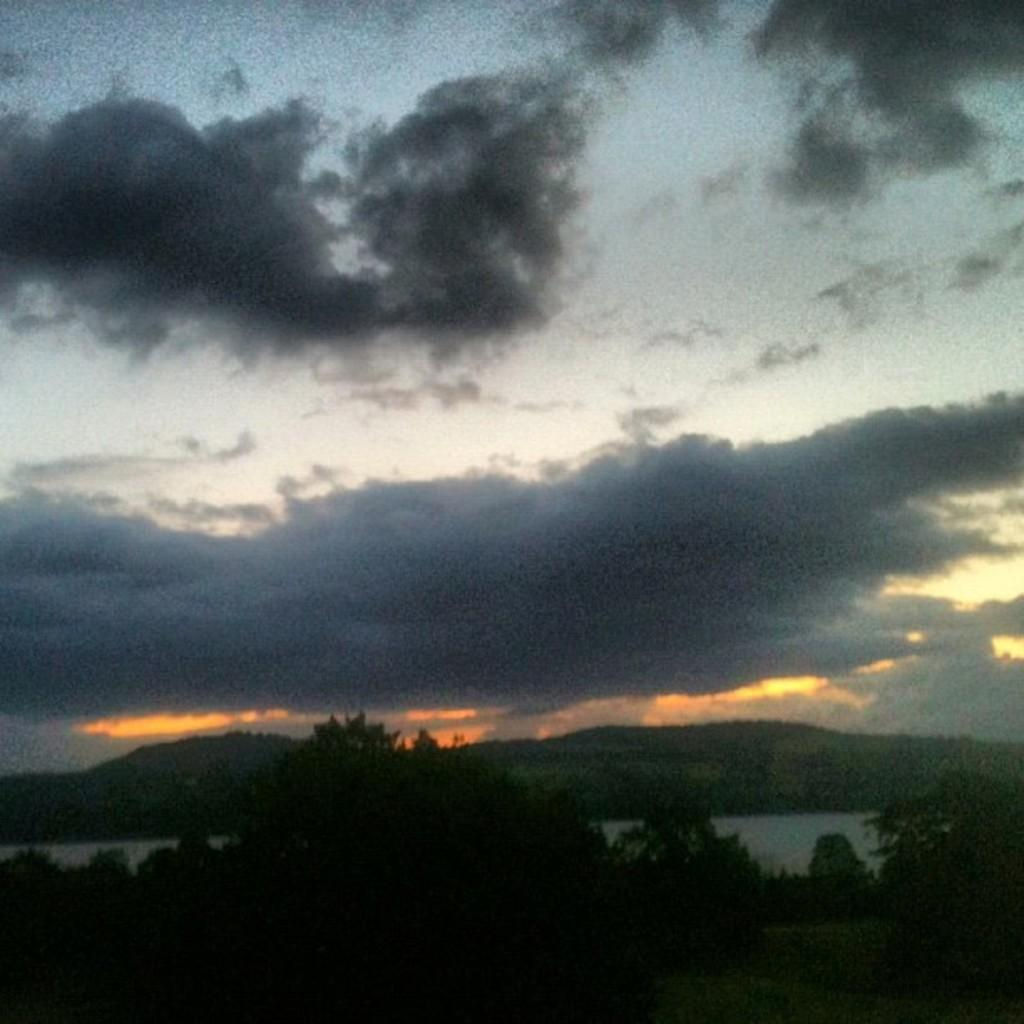What type of vegetation can be seen in the image? There are trees in the image. What body of water is present in the image? There is a lake in the image. What is the condition of the sky in the image? The sky is clouded in the image. What musical instrument is being played in the image? There is no musical instrument present in the image. How does the digestion process appear in the image? There is no reference to digestion in the image. 